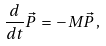Convert formula to latex. <formula><loc_0><loc_0><loc_500><loc_500>\frac { d } { d t } \vec { P } \, = \, - M \vec { P } \, ,</formula> 